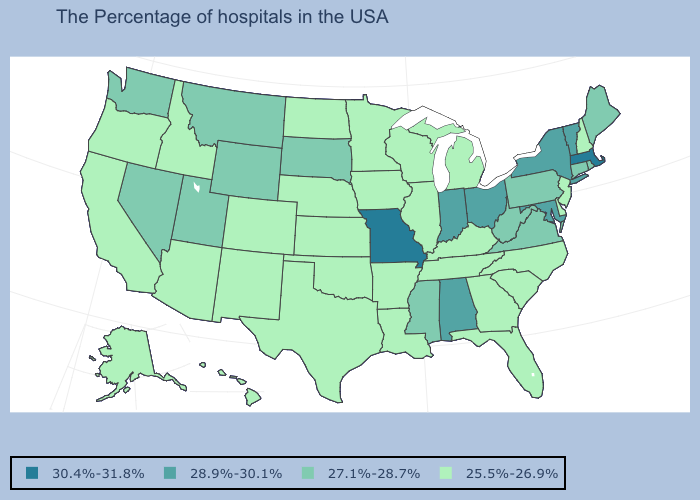Does the first symbol in the legend represent the smallest category?
Answer briefly. No. What is the value of Texas?
Concise answer only. 25.5%-26.9%. Does Missouri have the highest value in the MidWest?
Answer briefly. Yes. Does Minnesota have a higher value than Vermont?
Answer briefly. No. What is the highest value in states that border Florida?
Give a very brief answer. 28.9%-30.1%. Name the states that have a value in the range 30.4%-31.8%?
Write a very short answer. Massachusetts, Missouri. What is the highest value in the USA?
Give a very brief answer. 30.4%-31.8%. Name the states that have a value in the range 25.5%-26.9%?
Answer briefly. New Hampshire, New Jersey, Delaware, North Carolina, South Carolina, Florida, Georgia, Michigan, Kentucky, Tennessee, Wisconsin, Illinois, Louisiana, Arkansas, Minnesota, Iowa, Kansas, Nebraska, Oklahoma, Texas, North Dakota, Colorado, New Mexico, Arizona, Idaho, California, Oregon, Alaska, Hawaii. What is the value of Montana?
Give a very brief answer. 27.1%-28.7%. What is the lowest value in the USA?
Write a very short answer. 25.5%-26.9%. Which states have the lowest value in the West?
Write a very short answer. Colorado, New Mexico, Arizona, Idaho, California, Oregon, Alaska, Hawaii. Does Utah have a lower value than Maryland?
Quick response, please. Yes. Does New Hampshire have the lowest value in the Northeast?
Write a very short answer. Yes. Does Kansas have the highest value in the MidWest?
Quick response, please. No. Name the states that have a value in the range 27.1%-28.7%?
Answer briefly. Maine, Rhode Island, Connecticut, Pennsylvania, Virginia, West Virginia, Mississippi, South Dakota, Wyoming, Utah, Montana, Nevada, Washington. 